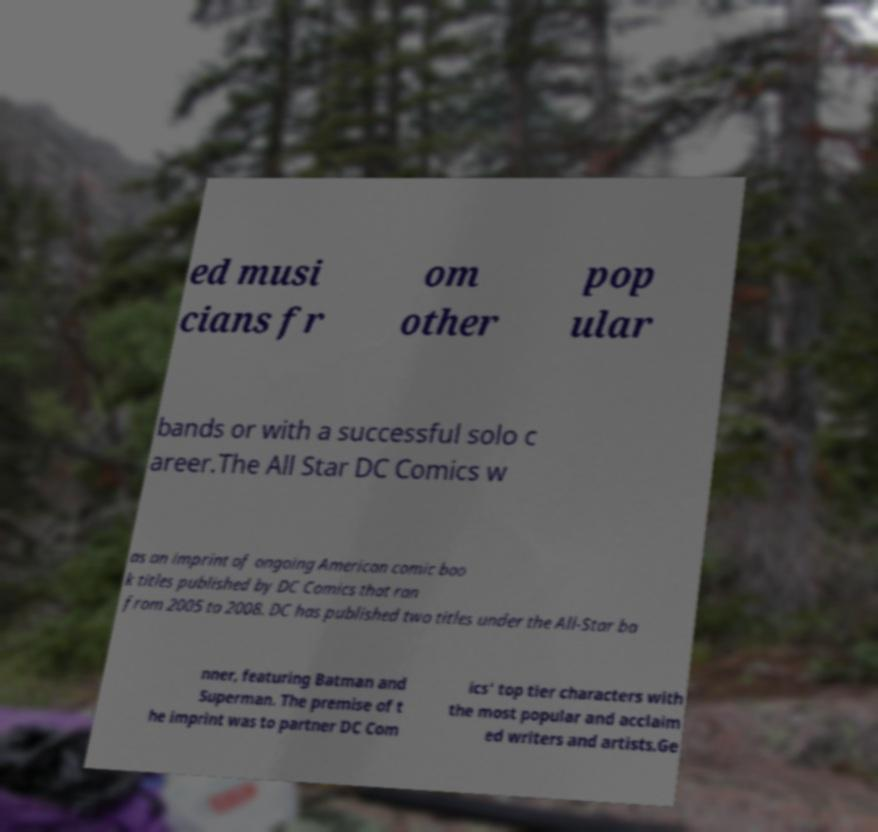I need the written content from this picture converted into text. Can you do that? ed musi cians fr om other pop ular bands or with a successful solo c areer.The All Star DC Comics w as an imprint of ongoing American comic boo k titles published by DC Comics that ran from 2005 to 2008. DC has published two titles under the All-Star ba nner, featuring Batman and Superman. The premise of t he imprint was to partner DC Com ics' top tier characters with the most popular and acclaim ed writers and artists.Ge 